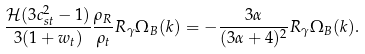Convert formula to latex. <formula><loc_0><loc_0><loc_500><loc_500>\frac { { \mathcal { H } } ( 3 c _ { s t } ^ { 2 } - 1 ) } { 3 ( 1 + w _ { t } ) } \frac { \rho _ { R } } { \rho _ { t } } R _ { \gamma } \Omega _ { B } ( k ) = - \frac { 3 \alpha } { ( 3 \alpha + 4 ) ^ { 2 } } R _ { \gamma } \Omega _ { B } ( k ) .</formula> 